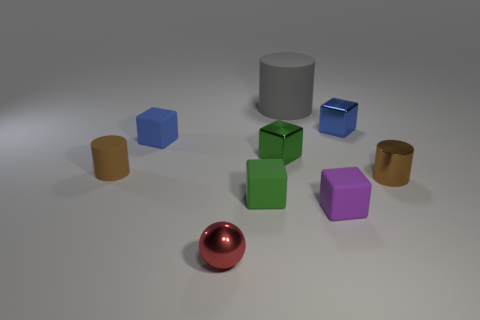Can you speculate about the size of these objects in relation to each other? While the exact size is uncertain without a reference object, the proportional differences between the objects suggest varying dimensions. The cylinder in the center seems to be the tallest object, while the small cubes could be considered similar in size creating a sense of depth. 